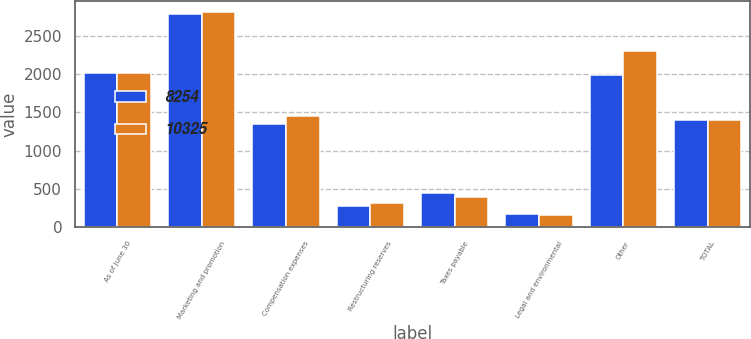Convert chart. <chart><loc_0><loc_0><loc_500><loc_500><stacked_bar_chart><ecel><fcel>As of June 30<fcel>Marketing and promotion<fcel>Compensation expenses<fcel>Restructuring reserves<fcel>Taxes payable<fcel>Legal and environmental<fcel>Other<fcel>TOTAL<nl><fcel>8254<fcel>2017<fcel>2792<fcel>1344<fcel>277<fcel>449<fcel>168<fcel>1994<fcel>1400.5<nl><fcel>10325<fcel>2016<fcel>2820<fcel>1457<fcel>315<fcel>397<fcel>158<fcel>2302<fcel>1400.5<nl></chart> 